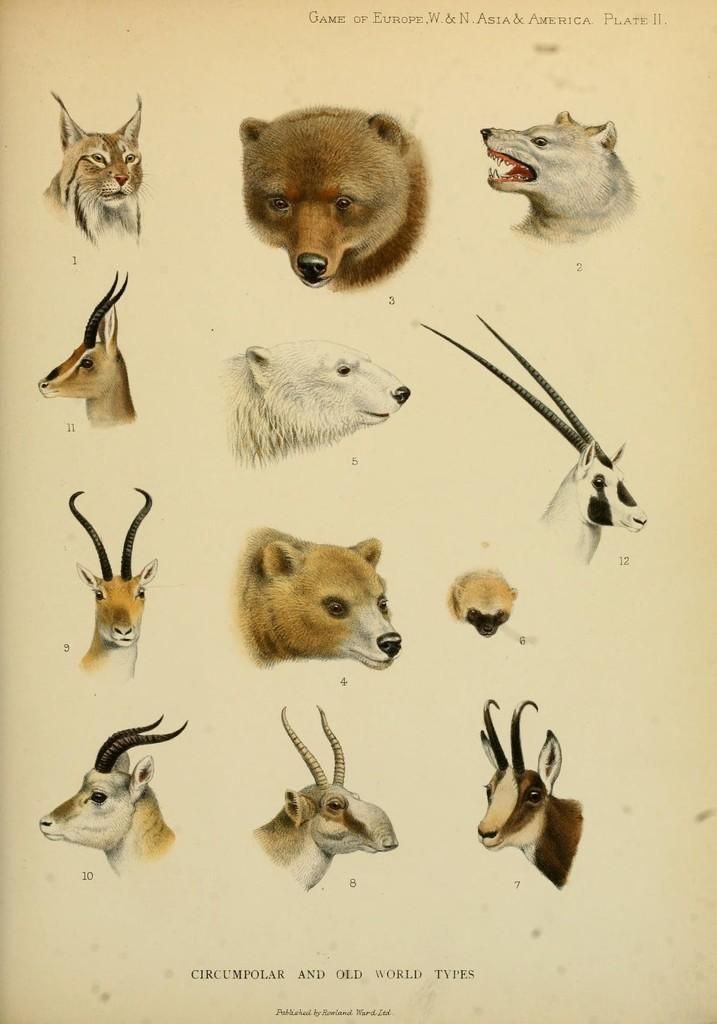What type of objects are depicted on the paper in the image? The image contains various animal heads on a paper. Can you name some of the depicted animal heads? The depicted animal heads include a bear, deer, wild cat, and wild goat. What type of spring can be seen supporting the animal heads in the image? There is no spring present in the image; the animal heads are depicted on a paper. 